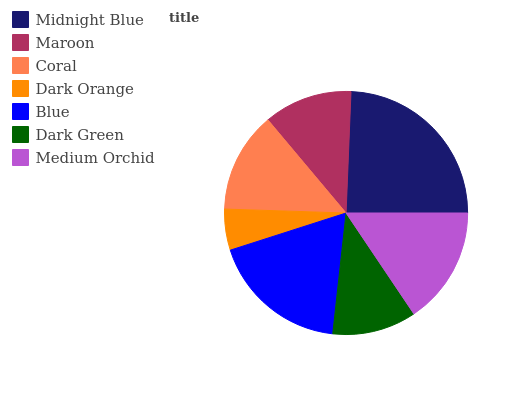Is Dark Orange the minimum?
Answer yes or no. Yes. Is Midnight Blue the maximum?
Answer yes or no. Yes. Is Maroon the minimum?
Answer yes or no. No. Is Maroon the maximum?
Answer yes or no. No. Is Midnight Blue greater than Maroon?
Answer yes or no. Yes. Is Maroon less than Midnight Blue?
Answer yes or no. Yes. Is Maroon greater than Midnight Blue?
Answer yes or no. No. Is Midnight Blue less than Maroon?
Answer yes or no. No. Is Coral the high median?
Answer yes or no. Yes. Is Coral the low median?
Answer yes or no. Yes. Is Dark Green the high median?
Answer yes or no. No. Is Dark Orange the low median?
Answer yes or no. No. 